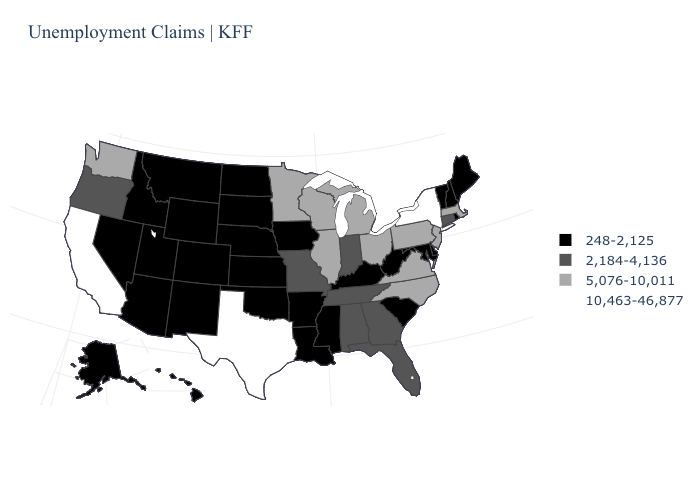What is the value of Idaho?
Concise answer only. 248-2,125. What is the value of Indiana?
Write a very short answer. 2,184-4,136. Which states hav the highest value in the South?
Write a very short answer. Texas. Does Texas have the highest value in the USA?
Quick response, please. Yes. Is the legend a continuous bar?
Keep it brief. No. What is the value of Massachusetts?
Short answer required. 5,076-10,011. What is the highest value in the USA?
Short answer required. 10,463-46,877. Name the states that have a value in the range 2,184-4,136?
Concise answer only. Alabama, Connecticut, Florida, Georgia, Indiana, Missouri, Oregon, Tennessee. What is the value of North Carolina?
Answer briefly. 5,076-10,011. Is the legend a continuous bar?
Be succinct. No. What is the value of Virginia?
Give a very brief answer. 5,076-10,011. What is the value of New York?
Keep it brief. 10,463-46,877. Name the states that have a value in the range 5,076-10,011?
Quick response, please. Illinois, Massachusetts, Michigan, Minnesota, New Jersey, North Carolina, Ohio, Pennsylvania, Virginia, Washington, Wisconsin. Does Tennessee have a higher value than Pennsylvania?
Concise answer only. No. What is the value of Florida?
Keep it brief. 2,184-4,136. 